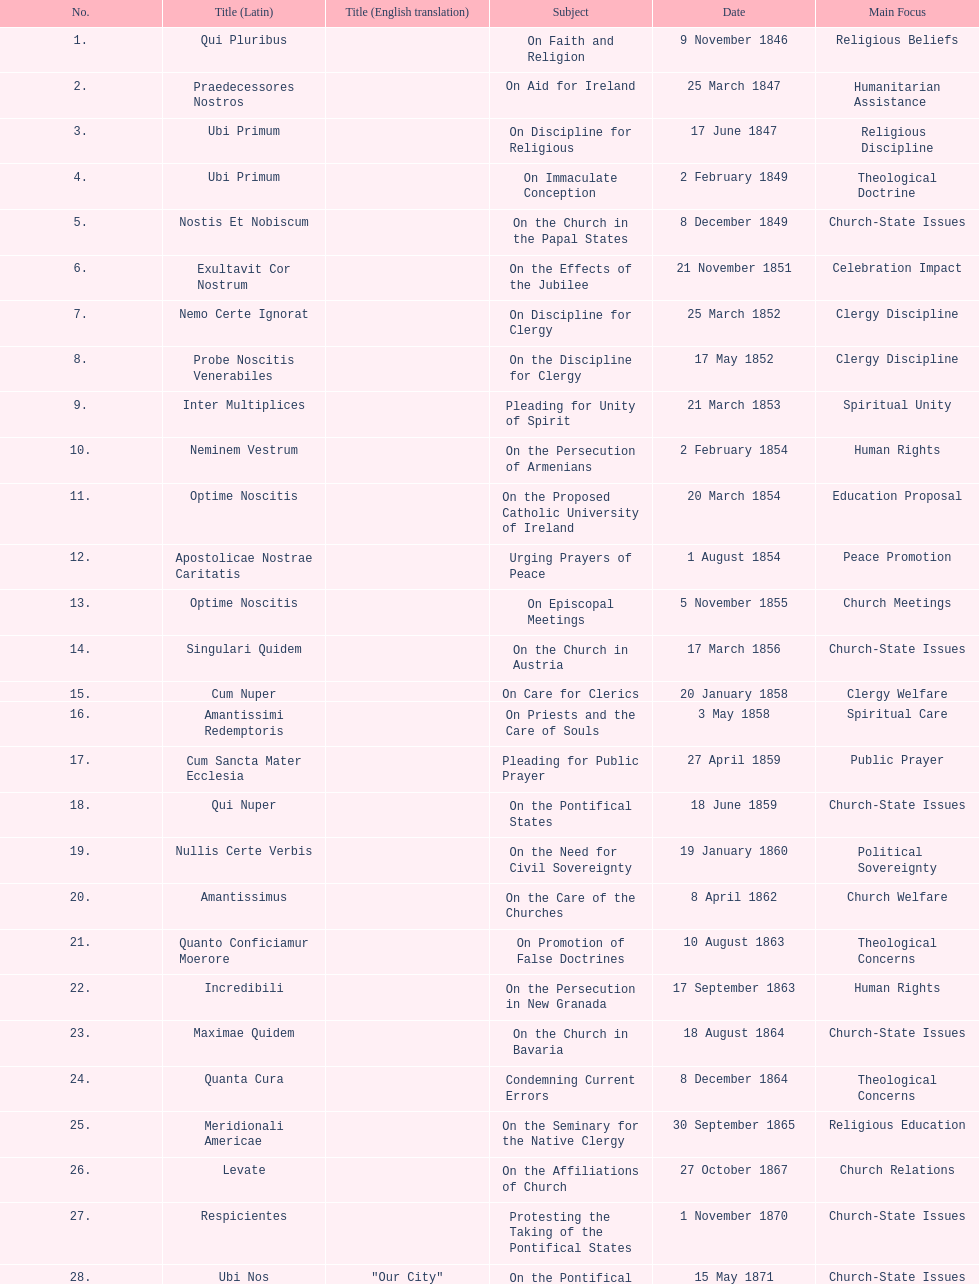What is the previous subject after on the effects of the jubilee? On the Church in the Papal States. 